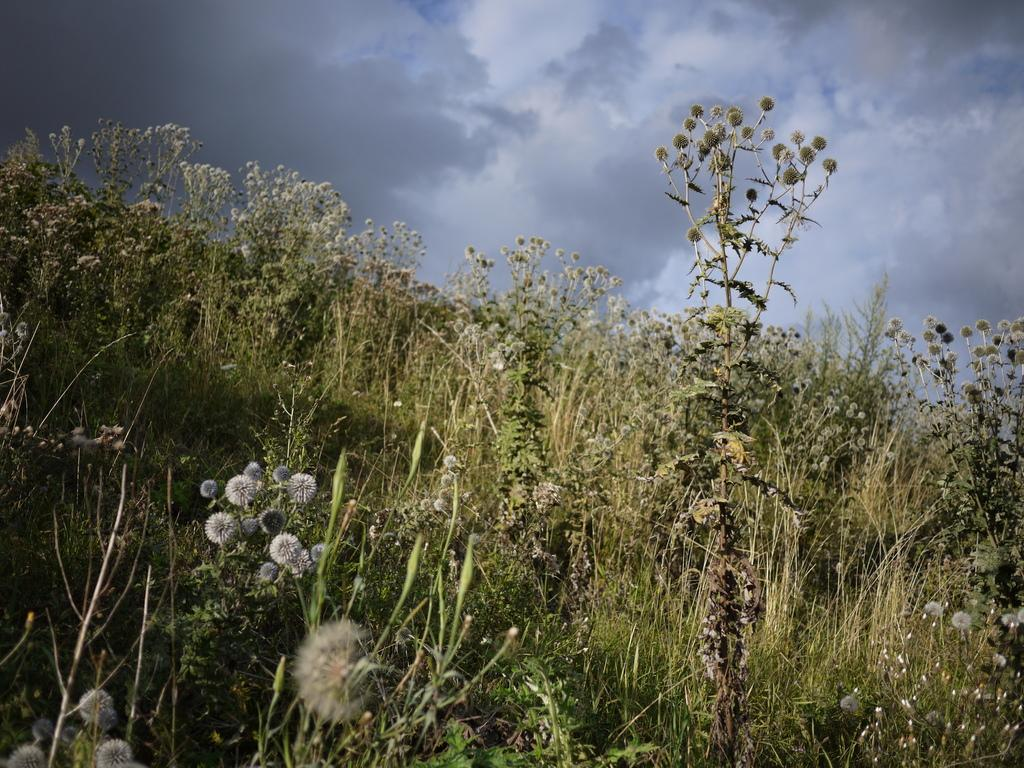What types of living organisms can be seen in the image? Plants and flowers are visible in the image. Can you describe the sky in the background of the image? There are clouds in the sky in the background of the image. What type of peace treaty is being signed in the image? There is no indication of a peace treaty or any signing event in the image; it features plants, flowers, and clouds. 